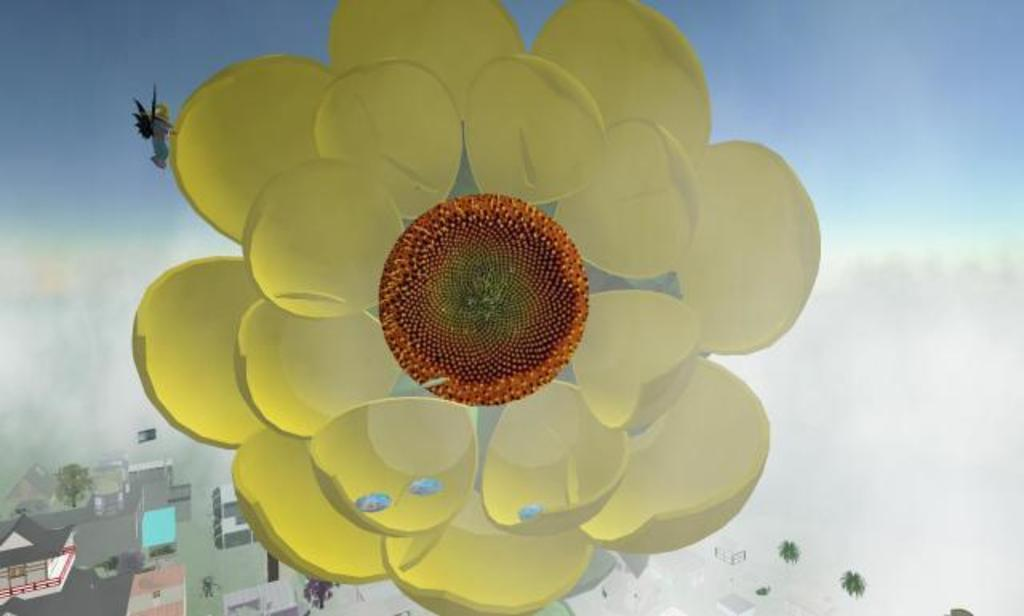What type of plant can be seen in the image? There is a flower in the image. What type of structures are visible in the image? There are houses in the image. What other natural elements can be seen in the image? There are trees in the image. How many apples are hanging from the trees in the image? There is no mention of apples in the image; it only features a flower, houses, and trees. What type of memory is being stored in the image? The image does not depict any memory storage devices or concepts; it simply shows a flower, houses, and trees. 